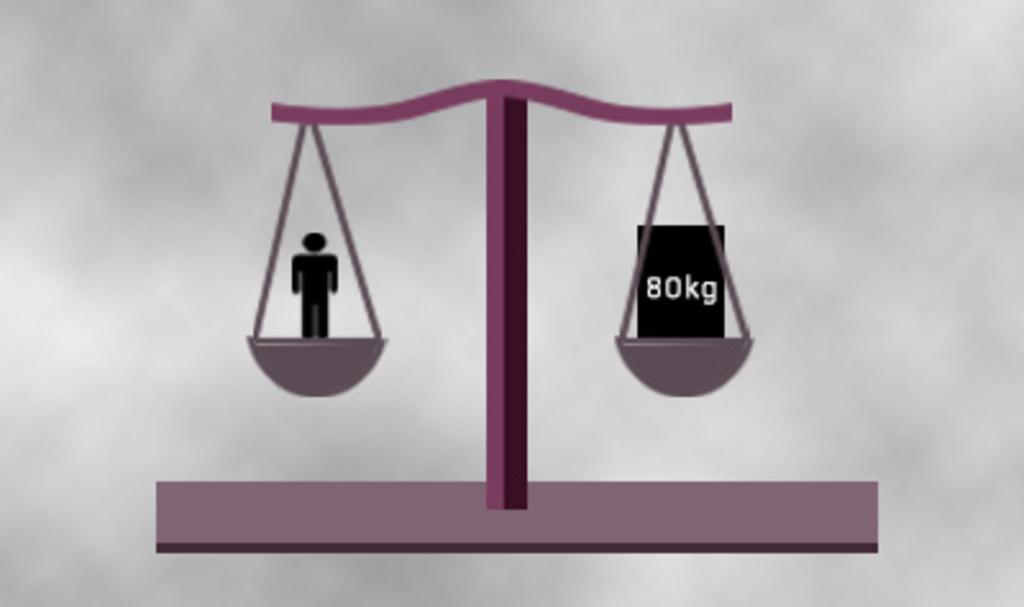What type of object is depicted in the image? There is a horizontal balance in the image. Can you describe any additional features of the image? There is a logo of a person in the image. How many pets are visible in the image? There are no pets present in the image. What type of suggestion is being made by the person in the logo? The image does not depict a specific suggestion being made by the person in the logo; it only shows the logo itself. 